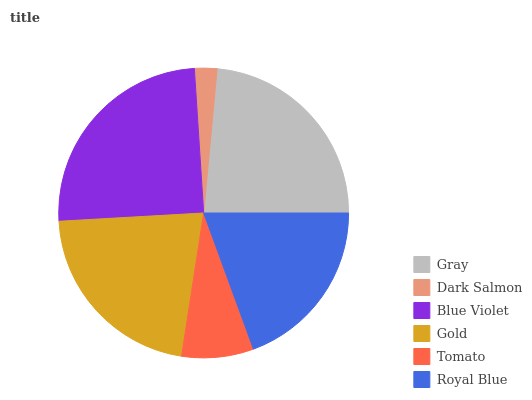Is Dark Salmon the minimum?
Answer yes or no. Yes. Is Blue Violet the maximum?
Answer yes or no. Yes. Is Blue Violet the minimum?
Answer yes or no. No. Is Dark Salmon the maximum?
Answer yes or no. No. Is Blue Violet greater than Dark Salmon?
Answer yes or no. Yes. Is Dark Salmon less than Blue Violet?
Answer yes or no. Yes. Is Dark Salmon greater than Blue Violet?
Answer yes or no. No. Is Blue Violet less than Dark Salmon?
Answer yes or no. No. Is Gold the high median?
Answer yes or no. Yes. Is Royal Blue the low median?
Answer yes or no. Yes. Is Dark Salmon the high median?
Answer yes or no. No. Is Blue Violet the low median?
Answer yes or no. No. 